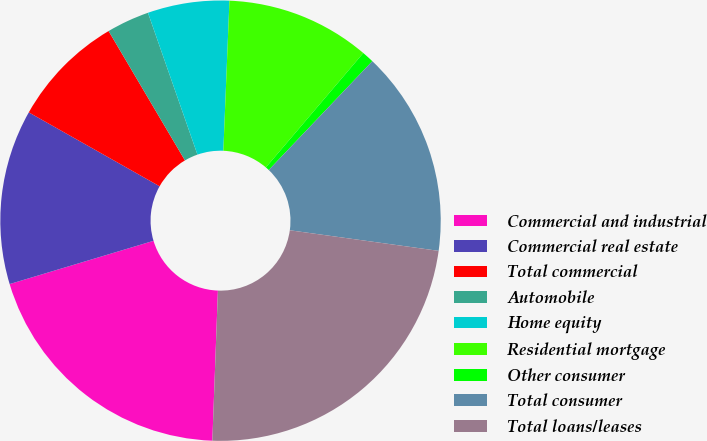Convert chart to OTSL. <chart><loc_0><loc_0><loc_500><loc_500><pie_chart><fcel>Commercial and industrial<fcel>Commercial real estate<fcel>Total commercial<fcel>Automobile<fcel>Home equity<fcel>Residential mortgage<fcel>Other consumer<fcel>Total consumer<fcel>Total loans/leases<nl><fcel>19.76%<fcel>12.83%<fcel>8.33%<fcel>3.14%<fcel>5.99%<fcel>10.58%<fcel>0.88%<fcel>15.08%<fcel>23.4%<nl></chart> 